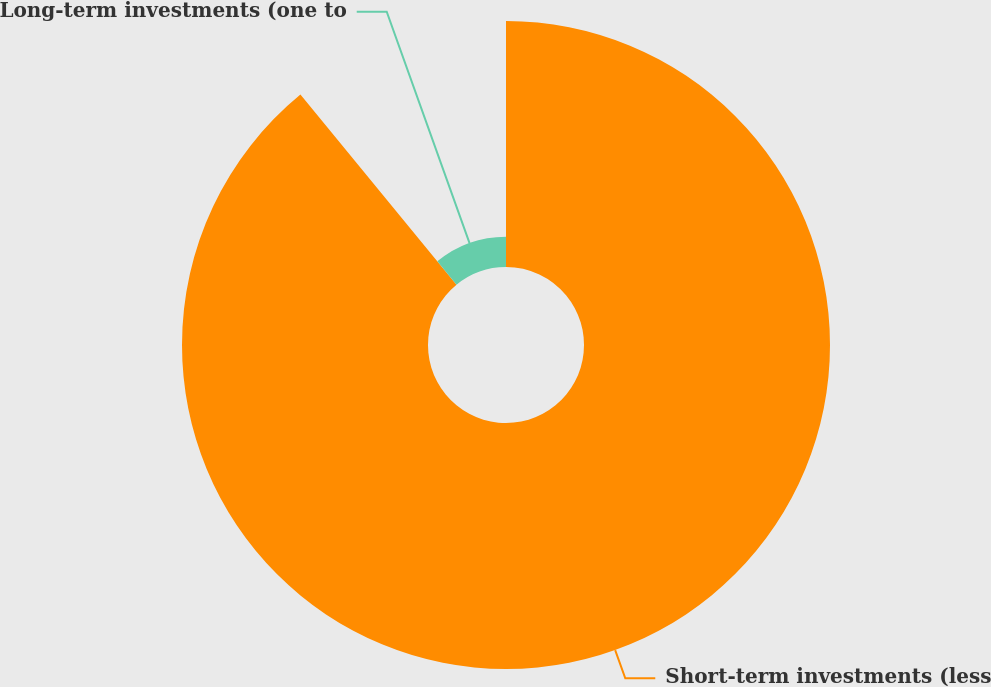<chart> <loc_0><loc_0><loc_500><loc_500><pie_chart><fcel>Short-term investments (less<fcel>Long-term investments (one to<nl><fcel>89.06%<fcel>10.94%<nl></chart> 